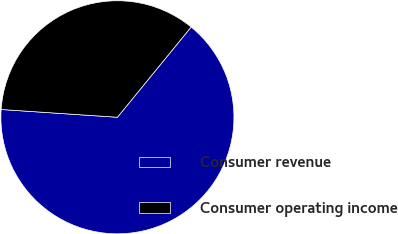Convert chart. <chart><loc_0><loc_0><loc_500><loc_500><pie_chart><fcel>Consumer revenue<fcel>Consumer operating income<nl><fcel>65.16%<fcel>34.84%<nl></chart> 